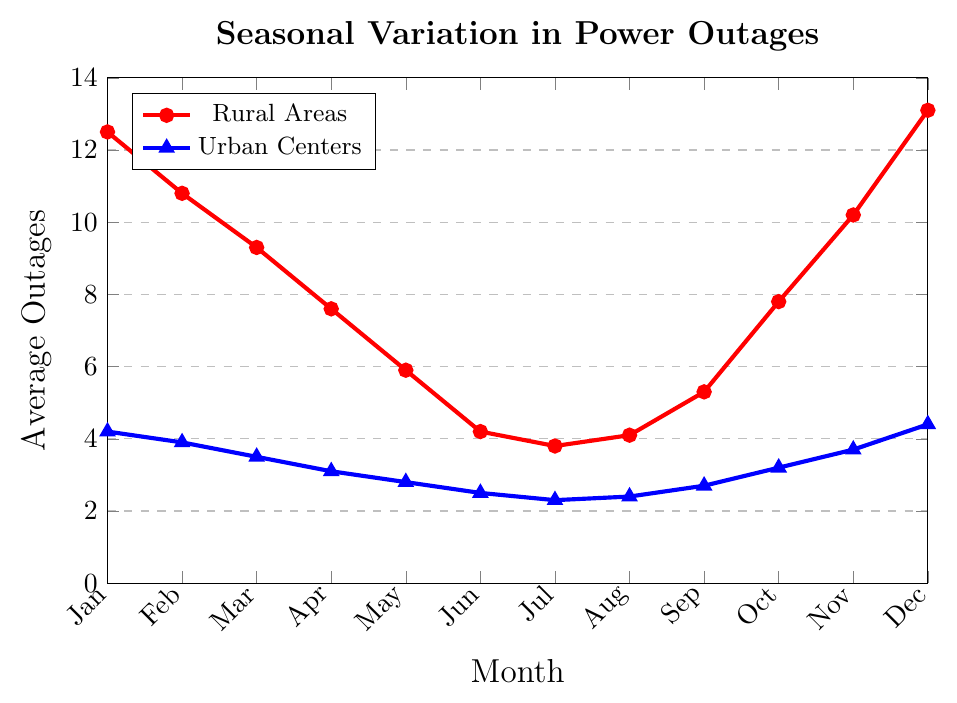How does the number of power outages in rural areas in January compare to the number in urban centers in the same month? The figure shows the power outages for both rural and urban areas each month. In January, rural areas have 12.5 outages while urban centers have 4.2 outages. Therefore, the number of power outages in rural areas in January is significantly higher than in urban centers.
Answer: Rural areas have 8.3 more outages Which month has the least number of power outages in rural areas? By visually inspecting the chart, we can see that the lowest point for the red line (indicating rural outages) is in July.
Answer: July What month shows the greatest difference in power outages between rural and urban areas? To find this, we look at the vertical distance between the red line (rural) and the blue line (urban) for each month. December shows the largest gap, with rural outages at 13.1 and urban outages at 4.4, a difference of 8.7 outages.
Answer: December Calculate the average number of outages in rural areas for the months of May, June, and July. The outages in rural areas are 5.9 in May, 4.2 in June, and 3.8 in July. Sum these values to get 5.9 + 4.2 + 3.8 = 13.9, and then divide by 3. The average is 13.9 / 3 = 4.63.
Answer: 4.63 Which month shows a slight increase in rural outages compared to the previous month? We need to identify where the red line goes up slightly compared to the previous month. August shows a slight increase from July (3.8 to 4.1).
Answer: August What is the range of outages for urban centers over the year? The minimum number of urban outages is 2.3 in July, and the maximum is 4.4 in December. The range is the difference between these values, 4.4 - 2.3 = 2.1.
Answer: 2.1 By how much do the power outages in rural areas decrease from January to June? The number of rural outages in January is 12.5, and in June it is 4.2. The decrease is calculated as 12.5 - 4.2 = 8.3.
Answer: 8.3 Is there any month where urban centers experience more outages than rural areas? By comparing the data points for each month, we see that there is no month where the blue line (urban) exceeds the red line (rural).
Answer: No What's the average number of power outages in urban centers for the first quarter of the year? The outages for January, February, and March are 4.2, 3.9, and 3.5 respectively. Adding these gives 4.2 + 3.9 + 3.5 = 11.6, and the average is 11.6 / 3 = 3.87.
Answer: 3.87 